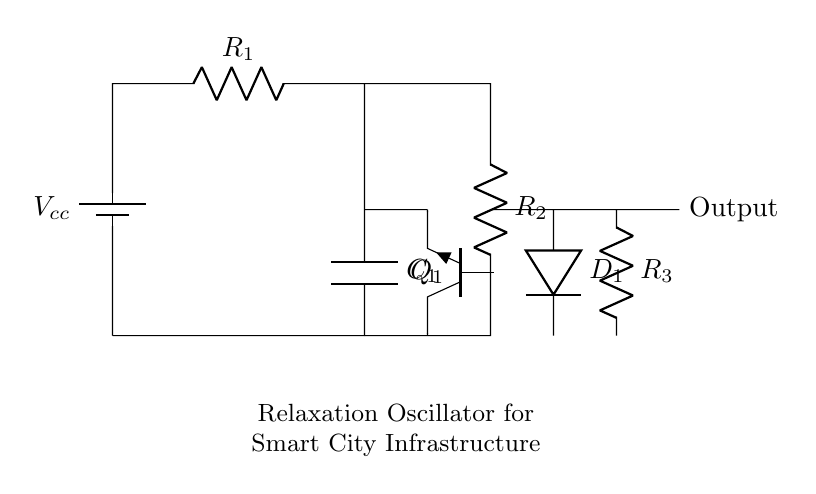What is the primary function of this circuit? The primary function of this circuit is to generate pulses, which is characteristic of a relaxation oscillator. This can be determined by the presence of a capacitor and resistor network that allows for periodic charging and discharging, leading to pulse generation.
Answer: pulse generation What type of transistor is used in the circuit? The circuit uses an NPN transistor, as indicated by the label denoting the component (Q1) as an npn type. The configuration of the transistor with respect to its connections further confirms its classification in conjunction with the other passive components.
Answer: NPN What is the role of the capacitor in this oscillator circuit? The capacitor (C1) is responsible for timing the oscillation by charging and discharging, which produces the pulse signal. In a relaxation oscillator, the timing characteristics are determined by the values of the capacitor and resistors, as they influence the rate of voltage change across the capacitor.
Answer: timing How many resistors are present in the circuit? There are three resistors present: R1, R2, and R3. Each resistor is identified by its labeled designations in the circuit diagram, confirming their quantity.
Answer: three What happens to the output signal if R2 increases? Increasing R2 will likely cause the frequency of the output signal to decrease because it affects the timing established by the RC network. An increase in resistance will slow the charging and discharging cycles of the capacitor, thus lengthening the time period of oscillation.
Answer: frequency decreases What type of diode is used in this circuit? The circuit contains a diode labeled as D1, though no specific type is indicated, typical assumptions can be made in the context of oscillator circuits. It is safe to conclude that standard diodes, commonly used in pulse circuits, are utilized without explicitly defining the make.
Answer: standard diode What is the purpose of the battery in this circuit? The battery (Vcc) provides the necessary voltage supply for the component operations in the circuit, enabling current flow through the resistors and enabling the oscillator to function effectively. Without this supply, the circuit would not operate.
Answer: voltage supply 